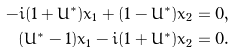Convert formula to latex. <formula><loc_0><loc_0><loc_500><loc_500>- i ( 1 + U ^ { * } ) x _ { 1 } + ( 1 - U ^ { * } ) x _ { 2 } & = 0 , \\ ( U ^ { * } - 1 ) x _ { 1 } - i ( 1 + U ^ { * } ) x _ { 2 } & = 0 .</formula> 